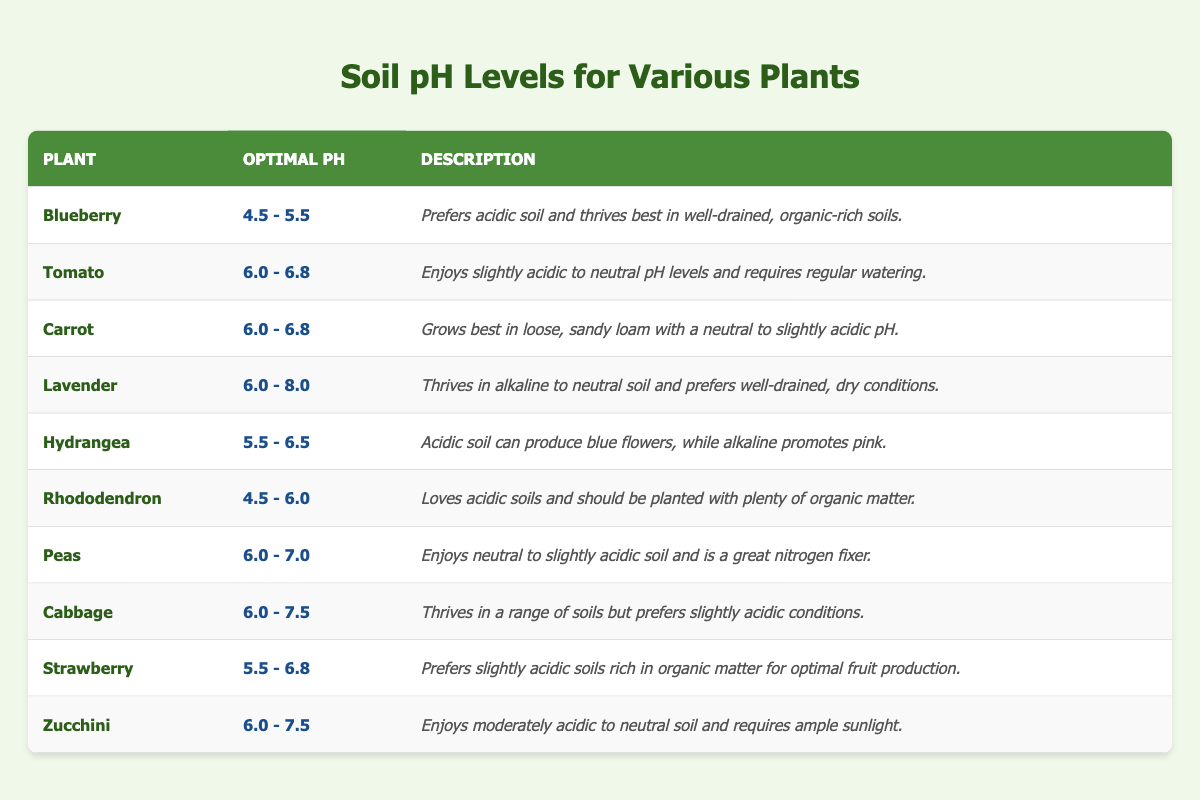What is the optimal pH range for Blueberry plants? The table lists Blueberry's optimal pH as "4.5 - 5.5".
Answer: 4.5 - 5.5 How many plants prefer a pH level of 6.0 or higher? The plants with pH levels of 6.0 or higher are Tomato, Carrot, Lavender, Peas, Cabbage, Strawberry, and Zucchini. This totals 7 plants.
Answer: 7 True or False: Hydrangeas thrive in alkaline soil. According to the table, Hydrangeas prefer acidic soil but can produce pink flowers in alkaline conditions, indicating they thrive in acidic soil. Thus, the statement is false.
Answer: False What is the difference in optimal pH levels between Rhododendron and Zucchini? Rhododendron's optimal pH is 4.5 - 6.0 and Zucchini's is 6.0 - 7.5. To find the difference, consider the highest pH values: 6.0 for Rhododendron and 7.5 for Zucchini. The difference is 7.5 - 6.0 = 1.5.
Answer: 1.5 Which plant requires the most acidic soil based on the table? The table shows that Blueberry and Rhododendron both prefer acidic soil, with Blueberry's range starting at 4.5. Since both share the same minimum, Blueberry is highlighted for its optimal range.
Answer: Blueberry If you want to achieve a neutral pH level for your garden, which plants would be suitable? Suitable plants for a neutral pH (around 7.0) include Peas, Cabbage, and Zucchini as their optimal pH ranges allow for neutral conditions.
Answer: Peas, Cabbage, Zucchini Are there any plants that thrive in alkaline soil? The table indicates that Lavender can thrive in alkaline soil, as its optimal pH range includes alkaline conditions (6.0 - 8.0).
Answer: Yes, Lavender What is the average optimal pH range for the plants that prefer slightly acidic soil? The plants preferring slightly acidic soil are Tomato, Carrot, Peas, Cabbage, Strawberry, and Zucchini, which have optimal pH ranges of 6.0 - 6.8 or slightly higher. First, identify their ranges, and then average the low and high values to derive the optimal pH: low end averages to be 6.0 and high end averages to be 6.1, making the overall average 6.05.
Answer: 6.05 How can the soil pH affect the color of Hydrangea flowers? The table describes how Hydrangea flowers can turn blue with acidic soil and pink with alkaline soil, indicating that soil pH directly affects flower color.
Answer: Soil pH affects flower color 